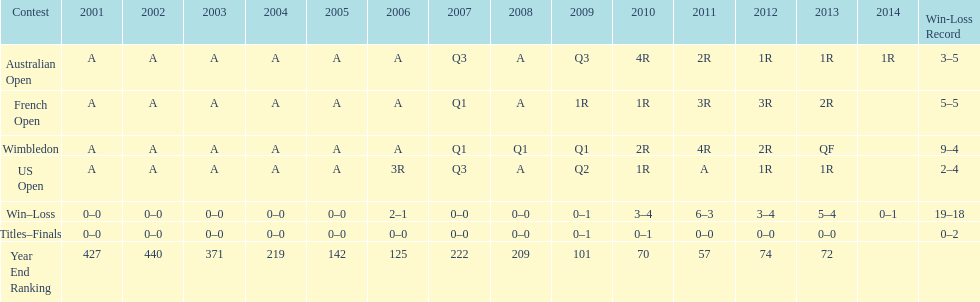Which year end ranking was higher, 2004 or 2011? 2011. 